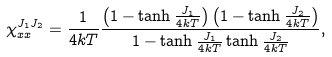Convert formula to latex. <formula><loc_0><loc_0><loc_500><loc_500>\chi _ { x x } ^ { J _ { 1 } J _ { 2 } } = \frac { 1 } { 4 k T } \frac { \left ( 1 - \tanh \frac { J _ { 1 } } { 4 k T } \right ) \left ( 1 - \tanh \frac { J _ { 2 } } { 4 k T } \right ) } { 1 - \tanh \frac { J _ { 1 } } { 4 k T } \tanh \frac { J _ { 2 } } { 4 k T } } ,</formula> 